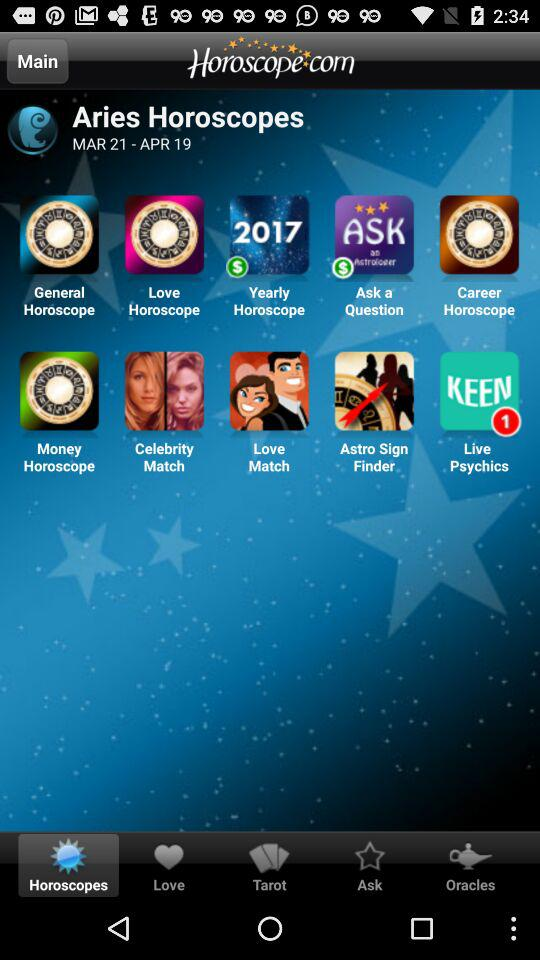What is the name of the application? The name of the application is "Horoscope.com". 